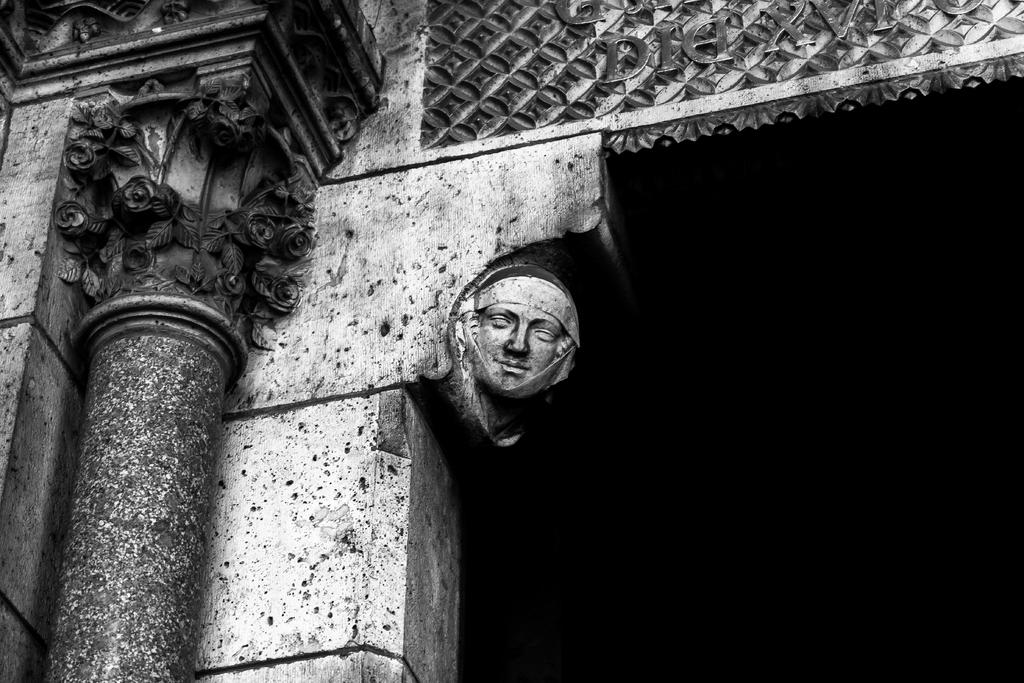What is depicted on the wall in the image? There is a statue of a face on the wall in the image. What other architectural feature can be seen in the image? There is a pillar in the image. Are there any decorative elements in the image? Yes, there are carvings in the image. What is the color of the background in the image? The background of the image is dark. What is the value of the face depicted on the wall in the image? The value of the face cannot be determined from the image, as it is a statue and not a currency or item with a monetary value. Can you see the ocean in the image? No, the ocean is not present in the image; it features a statue of a face, a pillar, carvings, and a dark background. 